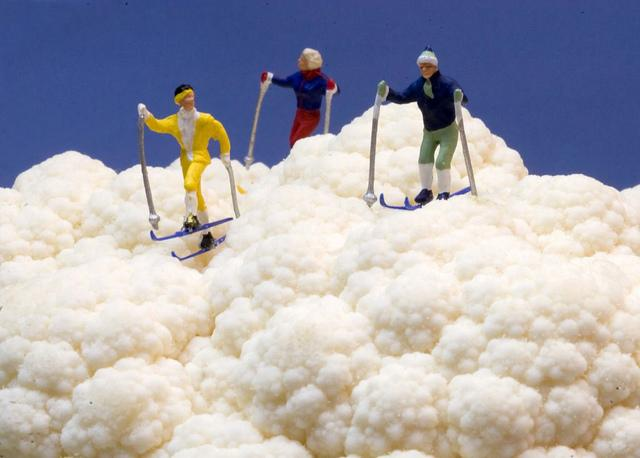What material was used to depict the snow in this art piece? cauliflower 